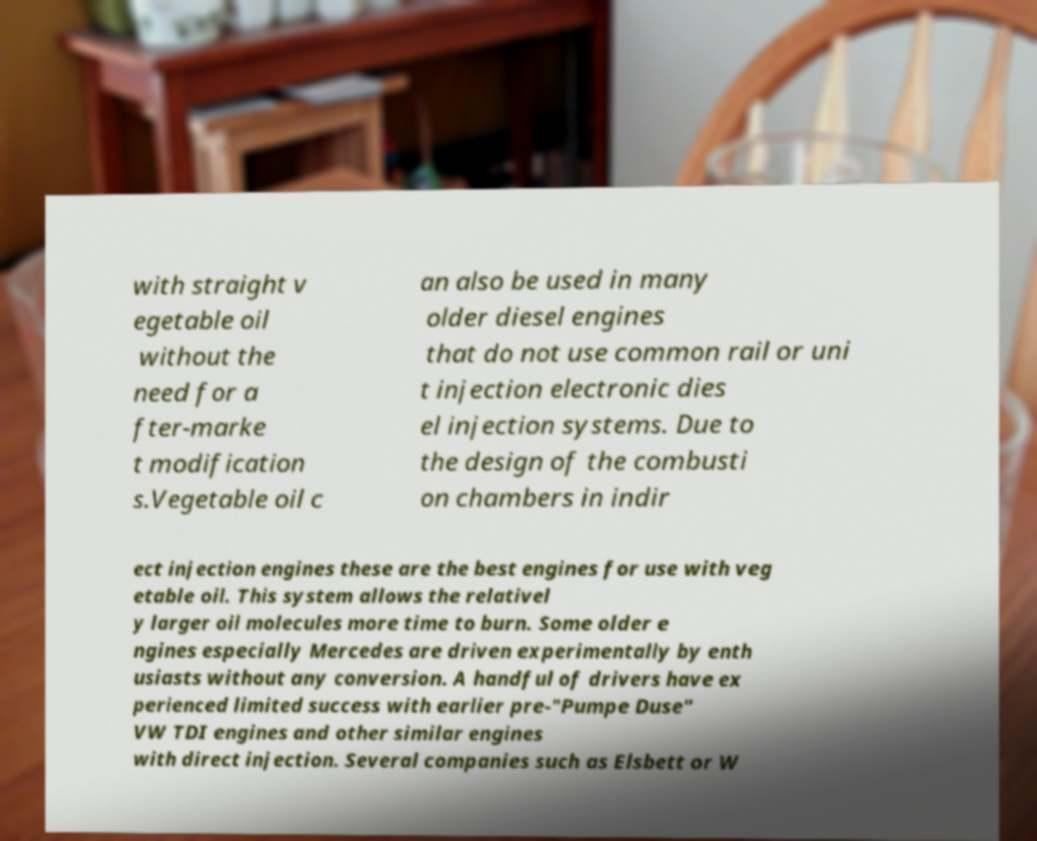I need the written content from this picture converted into text. Can you do that? with straight v egetable oil without the need for a fter-marke t modification s.Vegetable oil c an also be used in many older diesel engines that do not use common rail or uni t injection electronic dies el injection systems. Due to the design of the combusti on chambers in indir ect injection engines these are the best engines for use with veg etable oil. This system allows the relativel y larger oil molecules more time to burn. Some older e ngines especially Mercedes are driven experimentally by enth usiasts without any conversion. A handful of drivers have ex perienced limited success with earlier pre-"Pumpe Duse" VW TDI engines and other similar engines with direct injection. Several companies such as Elsbett or W 